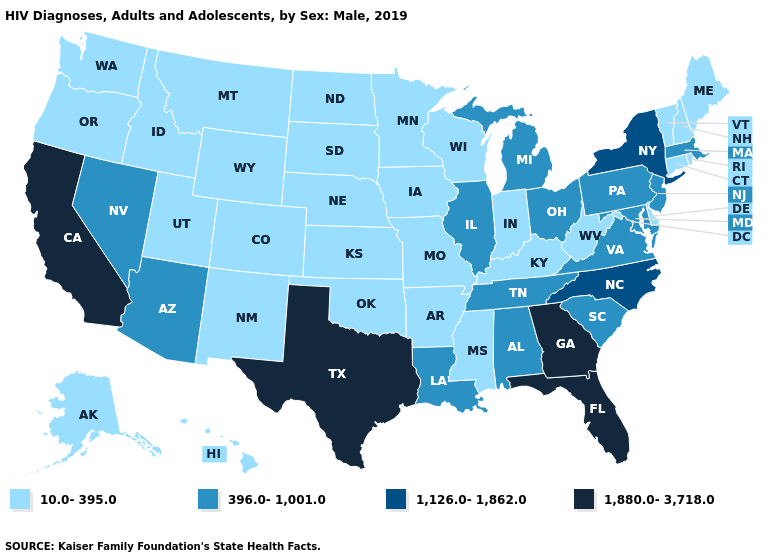What is the value of New York?
Give a very brief answer. 1,126.0-1,862.0. Name the states that have a value in the range 1,880.0-3,718.0?
Concise answer only. California, Florida, Georgia, Texas. Which states have the lowest value in the USA?
Short answer required. Alaska, Arkansas, Colorado, Connecticut, Delaware, Hawaii, Idaho, Indiana, Iowa, Kansas, Kentucky, Maine, Minnesota, Mississippi, Missouri, Montana, Nebraska, New Hampshire, New Mexico, North Dakota, Oklahoma, Oregon, Rhode Island, South Dakota, Utah, Vermont, Washington, West Virginia, Wisconsin, Wyoming. Does the first symbol in the legend represent the smallest category?
Give a very brief answer. Yes. What is the value of West Virginia?
Give a very brief answer. 10.0-395.0. Does Oregon have the highest value in the USA?
Answer briefly. No. What is the highest value in the USA?
Concise answer only. 1,880.0-3,718.0. Which states hav the highest value in the West?
Quick response, please. California. Among the states that border Rhode Island , does Massachusetts have the highest value?
Quick response, please. Yes. What is the value of Michigan?
Keep it brief. 396.0-1,001.0. Among the states that border Rhode Island , which have the highest value?
Keep it brief. Massachusetts. Name the states that have a value in the range 1,880.0-3,718.0?
Short answer required. California, Florida, Georgia, Texas. Name the states that have a value in the range 1,880.0-3,718.0?
Short answer required. California, Florida, Georgia, Texas. Name the states that have a value in the range 396.0-1,001.0?
Answer briefly. Alabama, Arizona, Illinois, Louisiana, Maryland, Massachusetts, Michigan, Nevada, New Jersey, Ohio, Pennsylvania, South Carolina, Tennessee, Virginia. Name the states that have a value in the range 1,880.0-3,718.0?
Give a very brief answer. California, Florida, Georgia, Texas. 